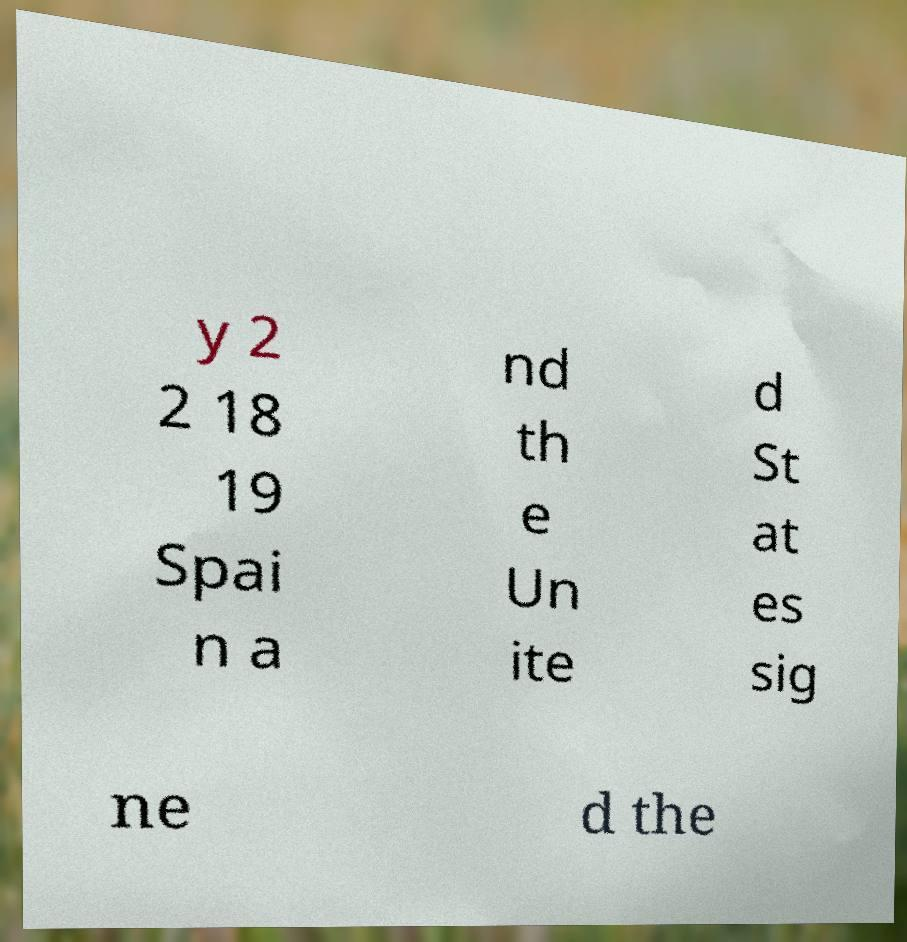Can you read and provide the text displayed in the image?This photo seems to have some interesting text. Can you extract and type it out for me? y 2 2 18 19 Spai n a nd th e Un ite d St at es sig ne d the 